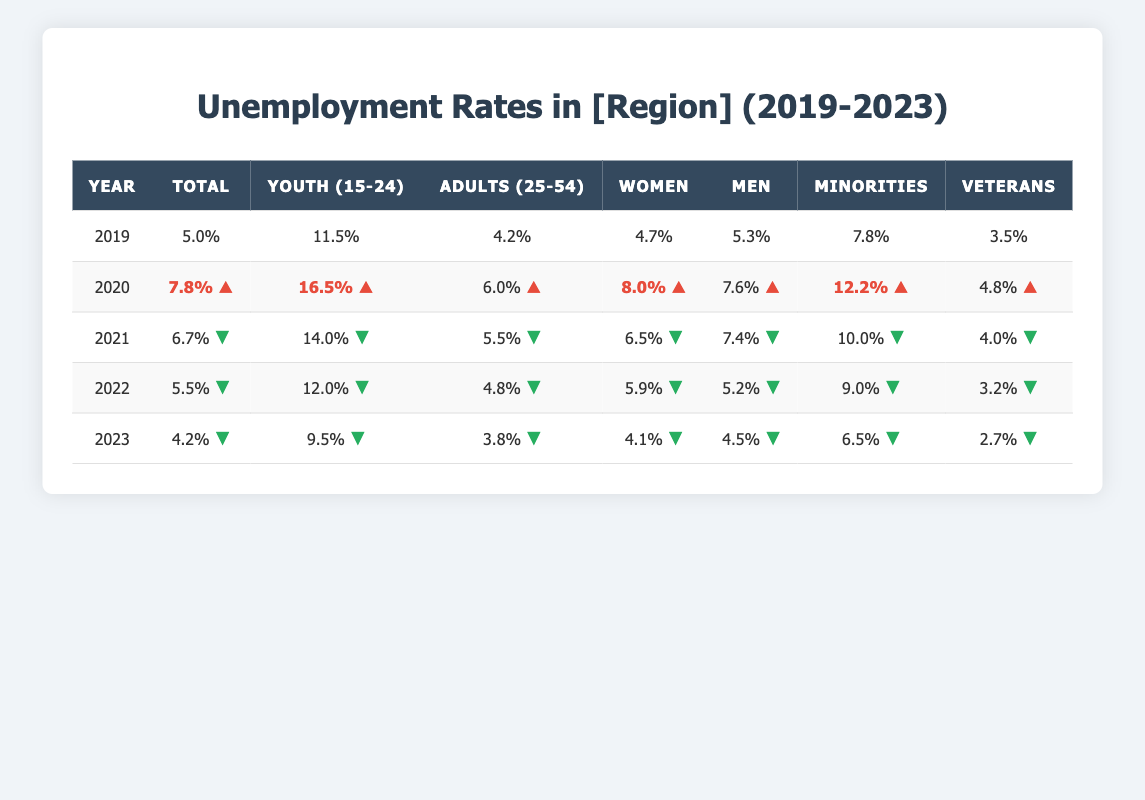What was the total unemployment rate in 2020? According to the table, the total unemployment rate for the year 2020 is directly listed as 7.8%.
Answer: 7.8% Which demographic had the highest unemployment rate in 2022? Looking at the demographic values for 2022, the highest unemployment rate is found among "Youth (Ages 15-24)" at 12.0%.
Answer: Youth (Ages 15-24) What is the difference in the total unemployment rate from 2019 to 2023? In 2019, the total unemployment rate was 5.0%, and in 2023, it decreased to 4.2%. The difference is 5.0% - 4.2% = 0.8%.
Answer: 0.8% Was the unemployment rate for veterans higher in 2021 than in 2019? In 2021, the unemployment rate for veterans was 4.0%, compared to 3.5% in 2019. Therefore, it is true that veterans had a higher unemployment rate in 2021 than in 2019.
Answer: Yes What was the average unemployment rate for adults (ages 25-54) over the five years? To find the average for adults (ages 25-54), we sum the values: (4.2 + 6.0 + 5.5 + 4.8 + 3.8) = 24.3%, and divide by 5, which gives 24.3% / 5 = 4.86%.
Answer: 4.86% How much did the youth unemployment rate decrease from 2020 to 2023? In 2020, the youth unemployment rate was 16.5%, and in 2023 it is 9.5%. The decrease is 16.5% - 9.5% = 7.0%.
Answer: 7.0% In which year did minorities experience their highest unemployment rate? Examining the data, minorities had their highest unemployment rate in 2020 at 12.2%.
Answer: 2020 What percentage of women were unemployed in 2022, and how does that compare to men in the same year? The unemployment rate for women in 2022 was 5.9%, while for men it was 5.2%. Comparatively, women had a higher unemployment rate than men by 5.9% - 5.2% = 0.7%.
Answer: Women had a 0.7% higher rate What is the overall trend in unemployment rates from 2019 to 2023? By analyzing the total unemployment rates across the years—5.0% (2019), 7.8% (2020), 6.7% (2021), 5.5% (2022), and 4.2% (2023)—the trend shows a decline over the five years.
Answer: Declining trend Which demographic had the lowest unemployment rate in 2023? In 2023, the unemployment rate for veterans was 2.7%, which is the lowest among all demographics.
Answer: Veterans 